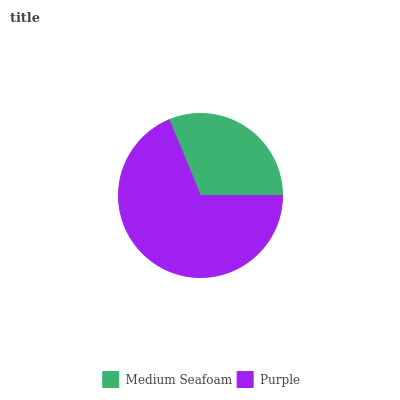Is Medium Seafoam the minimum?
Answer yes or no. Yes. Is Purple the maximum?
Answer yes or no. Yes. Is Purple the minimum?
Answer yes or no. No. Is Purple greater than Medium Seafoam?
Answer yes or no. Yes. Is Medium Seafoam less than Purple?
Answer yes or no. Yes. Is Medium Seafoam greater than Purple?
Answer yes or no. No. Is Purple less than Medium Seafoam?
Answer yes or no. No. Is Purple the high median?
Answer yes or no. Yes. Is Medium Seafoam the low median?
Answer yes or no. Yes. Is Medium Seafoam the high median?
Answer yes or no. No. Is Purple the low median?
Answer yes or no. No. 